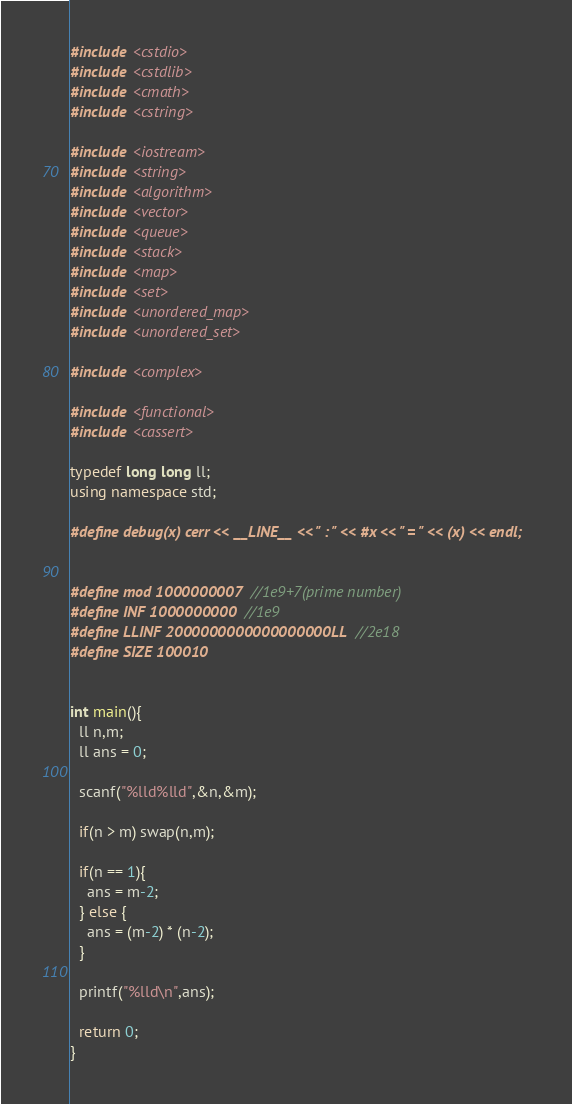<code> <loc_0><loc_0><loc_500><loc_500><_C++_>#include <cstdio>
#include <cstdlib>
#include <cmath>
#include <cstring>

#include <iostream>
#include <string>
#include <algorithm>
#include <vector>
#include <queue>
#include <stack>
#include <map>
#include <set>
#include <unordered_map>
#include <unordered_set>

#include <complex>

#include <functional>
#include <cassert>

typedef long long ll;
using namespace std;

#define debug(x) cerr << __LINE__ << " : " << #x << " = " << (x) << endl;


#define mod 1000000007 //1e9+7(prime number)
#define INF 1000000000 //1e9
#define LLINF 2000000000000000000LL //2e18
#define SIZE 100010


int main(){
  ll n,m;
  ll ans = 0;
  
  scanf("%lld%lld",&n,&m);

  if(n > m) swap(n,m);

  if(n == 1){
    ans = m-2;
  } else {
    ans = (m-2) * (n-2);
  }

  printf("%lld\n",ans);
  
  return 0;
}

</code> 